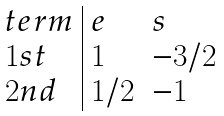<formula> <loc_0><loc_0><loc_500><loc_500>\begin{array} { l | l l } t e r m & e & s \\ 1 s t & 1 & - 3 / 2 \\ 2 n d & 1 / 2 & - 1 \\ \end{array}</formula> 